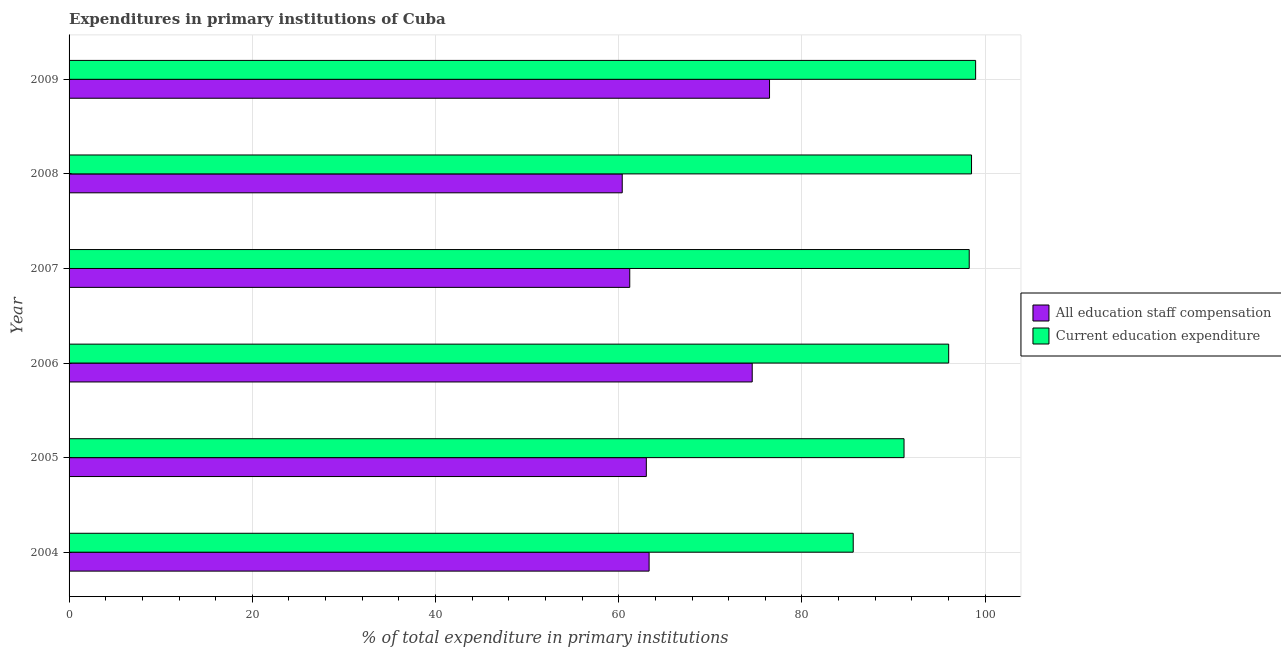How many groups of bars are there?
Provide a short and direct response. 6. Are the number of bars per tick equal to the number of legend labels?
Give a very brief answer. Yes. Are the number of bars on each tick of the Y-axis equal?
Your answer should be compact. Yes. How many bars are there on the 4th tick from the bottom?
Ensure brevity in your answer.  2. In how many cases, is the number of bars for a given year not equal to the number of legend labels?
Provide a succinct answer. 0. What is the expenditure in education in 2004?
Your response must be concise. 85.59. Across all years, what is the maximum expenditure in education?
Your answer should be compact. 98.96. Across all years, what is the minimum expenditure in staff compensation?
Ensure brevity in your answer.  60.38. In which year was the expenditure in staff compensation minimum?
Offer a very short reply. 2008. What is the total expenditure in staff compensation in the graph?
Keep it short and to the point. 398.94. What is the difference between the expenditure in staff compensation in 2004 and that in 2009?
Make the answer very short. -13.14. What is the difference between the expenditure in education in 2008 and the expenditure in staff compensation in 2004?
Provide a short and direct response. 35.19. What is the average expenditure in education per year?
Offer a terse response. 94.75. In the year 2005, what is the difference between the expenditure in staff compensation and expenditure in education?
Provide a short and direct response. -28.13. What is the ratio of the expenditure in education in 2008 to that in 2009?
Your answer should be compact. 0.99. Is the difference between the expenditure in education in 2004 and 2005 greater than the difference between the expenditure in staff compensation in 2004 and 2005?
Keep it short and to the point. No. What is the difference between the highest and the second highest expenditure in education?
Keep it short and to the point. 0.45. What is the difference between the highest and the lowest expenditure in education?
Keep it short and to the point. 13.36. In how many years, is the expenditure in education greater than the average expenditure in education taken over all years?
Your answer should be very brief. 4. Is the sum of the expenditure in education in 2004 and 2005 greater than the maximum expenditure in staff compensation across all years?
Give a very brief answer. Yes. What does the 2nd bar from the top in 2009 represents?
Your answer should be compact. All education staff compensation. What does the 2nd bar from the bottom in 2005 represents?
Your answer should be very brief. Current education expenditure. How many bars are there?
Your answer should be compact. 12. Are all the bars in the graph horizontal?
Give a very brief answer. Yes. How many years are there in the graph?
Keep it short and to the point. 6. What is the difference between two consecutive major ticks on the X-axis?
Your answer should be compact. 20. Are the values on the major ticks of X-axis written in scientific E-notation?
Make the answer very short. No. Does the graph contain any zero values?
Make the answer very short. No. Does the graph contain grids?
Provide a short and direct response. Yes. What is the title of the graph?
Provide a short and direct response. Expenditures in primary institutions of Cuba. Does "Constant 2005 US$" appear as one of the legend labels in the graph?
Your answer should be very brief. No. What is the label or title of the X-axis?
Make the answer very short. % of total expenditure in primary institutions. What is the label or title of the Y-axis?
Your answer should be compact. Year. What is the % of total expenditure in primary institutions of All education staff compensation in 2004?
Offer a terse response. 63.31. What is the % of total expenditure in primary institutions in Current education expenditure in 2004?
Your answer should be very brief. 85.59. What is the % of total expenditure in primary institutions in All education staff compensation in 2005?
Your response must be concise. 63.01. What is the % of total expenditure in primary institutions of Current education expenditure in 2005?
Keep it short and to the point. 91.14. What is the % of total expenditure in primary institutions in All education staff compensation in 2006?
Offer a very short reply. 74.57. What is the % of total expenditure in primary institutions of Current education expenditure in 2006?
Offer a very short reply. 96.02. What is the % of total expenditure in primary institutions of All education staff compensation in 2007?
Keep it short and to the point. 61.2. What is the % of total expenditure in primary institutions of Current education expenditure in 2007?
Give a very brief answer. 98.26. What is the % of total expenditure in primary institutions in All education staff compensation in 2008?
Your answer should be compact. 60.38. What is the % of total expenditure in primary institutions in Current education expenditure in 2008?
Offer a terse response. 98.51. What is the % of total expenditure in primary institutions of All education staff compensation in 2009?
Offer a very short reply. 76.46. What is the % of total expenditure in primary institutions in Current education expenditure in 2009?
Offer a terse response. 98.96. Across all years, what is the maximum % of total expenditure in primary institutions in All education staff compensation?
Offer a very short reply. 76.46. Across all years, what is the maximum % of total expenditure in primary institutions of Current education expenditure?
Your answer should be compact. 98.96. Across all years, what is the minimum % of total expenditure in primary institutions in All education staff compensation?
Your response must be concise. 60.38. Across all years, what is the minimum % of total expenditure in primary institutions in Current education expenditure?
Provide a succinct answer. 85.59. What is the total % of total expenditure in primary institutions of All education staff compensation in the graph?
Offer a very short reply. 398.94. What is the total % of total expenditure in primary institutions of Current education expenditure in the graph?
Provide a succinct answer. 568.47. What is the difference between the % of total expenditure in primary institutions in All education staff compensation in 2004 and that in 2005?
Offer a very short reply. 0.3. What is the difference between the % of total expenditure in primary institutions in Current education expenditure in 2004 and that in 2005?
Provide a short and direct response. -5.55. What is the difference between the % of total expenditure in primary institutions of All education staff compensation in 2004 and that in 2006?
Give a very brief answer. -11.26. What is the difference between the % of total expenditure in primary institutions in Current education expenditure in 2004 and that in 2006?
Make the answer very short. -10.42. What is the difference between the % of total expenditure in primary institutions of All education staff compensation in 2004 and that in 2007?
Ensure brevity in your answer.  2.11. What is the difference between the % of total expenditure in primary institutions in Current education expenditure in 2004 and that in 2007?
Offer a very short reply. -12.66. What is the difference between the % of total expenditure in primary institutions in All education staff compensation in 2004 and that in 2008?
Make the answer very short. 2.93. What is the difference between the % of total expenditure in primary institutions of Current education expenditure in 2004 and that in 2008?
Your answer should be very brief. -12.91. What is the difference between the % of total expenditure in primary institutions of All education staff compensation in 2004 and that in 2009?
Your answer should be very brief. -13.15. What is the difference between the % of total expenditure in primary institutions of Current education expenditure in 2004 and that in 2009?
Offer a very short reply. -13.36. What is the difference between the % of total expenditure in primary institutions in All education staff compensation in 2005 and that in 2006?
Your response must be concise. -11.56. What is the difference between the % of total expenditure in primary institutions in Current education expenditure in 2005 and that in 2006?
Your response must be concise. -4.87. What is the difference between the % of total expenditure in primary institutions in All education staff compensation in 2005 and that in 2007?
Your response must be concise. 1.81. What is the difference between the % of total expenditure in primary institutions of Current education expenditure in 2005 and that in 2007?
Ensure brevity in your answer.  -7.12. What is the difference between the % of total expenditure in primary institutions of All education staff compensation in 2005 and that in 2008?
Keep it short and to the point. 2.63. What is the difference between the % of total expenditure in primary institutions in Current education expenditure in 2005 and that in 2008?
Offer a very short reply. -7.37. What is the difference between the % of total expenditure in primary institutions in All education staff compensation in 2005 and that in 2009?
Offer a very short reply. -13.45. What is the difference between the % of total expenditure in primary institutions of Current education expenditure in 2005 and that in 2009?
Your answer should be compact. -7.81. What is the difference between the % of total expenditure in primary institutions in All education staff compensation in 2006 and that in 2007?
Ensure brevity in your answer.  13.37. What is the difference between the % of total expenditure in primary institutions of Current education expenditure in 2006 and that in 2007?
Offer a very short reply. -2.24. What is the difference between the % of total expenditure in primary institutions of All education staff compensation in 2006 and that in 2008?
Your response must be concise. 14.19. What is the difference between the % of total expenditure in primary institutions of Current education expenditure in 2006 and that in 2008?
Your answer should be very brief. -2.49. What is the difference between the % of total expenditure in primary institutions of All education staff compensation in 2006 and that in 2009?
Offer a terse response. -1.89. What is the difference between the % of total expenditure in primary institutions in Current education expenditure in 2006 and that in 2009?
Your answer should be very brief. -2.94. What is the difference between the % of total expenditure in primary institutions in All education staff compensation in 2007 and that in 2008?
Your answer should be compact. 0.82. What is the difference between the % of total expenditure in primary institutions in Current education expenditure in 2007 and that in 2008?
Offer a terse response. -0.25. What is the difference between the % of total expenditure in primary institutions of All education staff compensation in 2007 and that in 2009?
Offer a terse response. -15.26. What is the difference between the % of total expenditure in primary institutions in Current education expenditure in 2007 and that in 2009?
Your answer should be compact. -0.7. What is the difference between the % of total expenditure in primary institutions of All education staff compensation in 2008 and that in 2009?
Provide a short and direct response. -16.08. What is the difference between the % of total expenditure in primary institutions in Current education expenditure in 2008 and that in 2009?
Ensure brevity in your answer.  -0.45. What is the difference between the % of total expenditure in primary institutions in All education staff compensation in 2004 and the % of total expenditure in primary institutions in Current education expenditure in 2005?
Your answer should be compact. -27.83. What is the difference between the % of total expenditure in primary institutions of All education staff compensation in 2004 and the % of total expenditure in primary institutions of Current education expenditure in 2006?
Give a very brief answer. -32.7. What is the difference between the % of total expenditure in primary institutions in All education staff compensation in 2004 and the % of total expenditure in primary institutions in Current education expenditure in 2007?
Provide a succinct answer. -34.94. What is the difference between the % of total expenditure in primary institutions of All education staff compensation in 2004 and the % of total expenditure in primary institutions of Current education expenditure in 2008?
Provide a succinct answer. -35.19. What is the difference between the % of total expenditure in primary institutions in All education staff compensation in 2004 and the % of total expenditure in primary institutions in Current education expenditure in 2009?
Your answer should be compact. -35.64. What is the difference between the % of total expenditure in primary institutions of All education staff compensation in 2005 and the % of total expenditure in primary institutions of Current education expenditure in 2006?
Provide a succinct answer. -33. What is the difference between the % of total expenditure in primary institutions in All education staff compensation in 2005 and the % of total expenditure in primary institutions in Current education expenditure in 2007?
Provide a short and direct response. -35.25. What is the difference between the % of total expenditure in primary institutions in All education staff compensation in 2005 and the % of total expenditure in primary institutions in Current education expenditure in 2008?
Make the answer very short. -35.5. What is the difference between the % of total expenditure in primary institutions of All education staff compensation in 2005 and the % of total expenditure in primary institutions of Current education expenditure in 2009?
Make the answer very short. -35.94. What is the difference between the % of total expenditure in primary institutions of All education staff compensation in 2006 and the % of total expenditure in primary institutions of Current education expenditure in 2007?
Offer a terse response. -23.69. What is the difference between the % of total expenditure in primary institutions in All education staff compensation in 2006 and the % of total expenditure in primary institutions in Current education expenditure in 2008?
Make the answer very short. -23.94. What is the difference between the % of total expenditure in primary institutions in All education staff compensation in 2006 and the % of total expenditure in primary institutions in Current education expenditure in 2009?
Your answer should be very brief. -24.39. What is the difference between the % of total expenditure in primary institutions in All education staff compensation in 2007 and the % of total expenditure in primary institutions in Current education expenditure in 2008?
Your response must be concise. -37.31. What is the difference between the % of total expenditure in primary institutions of All education staff compensation in 2007 and the % of total expenditure in primary institutions of Current education expenditure in 2009?
Provide a succinct answer. -37.75. What is the difference between the % of total expenditure in primary institutions in All education staff compensation in 2008 and the % of total expenditure in primary institutions in Current education expenditure in 2009?
Keep it short and to the point. -38.57. What is the average % of total expenditure in primary institutions in All education staff compensation per year?
Give a very brief answer. 66.49. What is the average % of total expenditure in primary institutions in Current education expenditure per year?
Your response must be concise. 94.75. In the year 2004, what is the difference between the % of total expenditure in primary institutions in All education staff compensation and % of total expenditure in primary institutions in Current education expenditure?
Provide a short and direct response. -22.28. In the year 2005, what is the difference between the % of total expenditure in primary institutions of All education staff compensation and % of total expenditure in primary institutions of Current education expenditure?
Your answer should be compact. -28.13. In the year 2006, what is the difference between the % of total expenditure in primary institutions in All education staff compensation and % of total expenditure in primary institutions in Current education expenditure?
Offer a terse response. -21.45. In the year 2007, what is the difference between the % of total expenditure in primary institutions in All education staff compensation and % of total expenditure in primary institutions in Current education expenditure?
Make the answer very short. -37.06. In the year 2008, what is the difference between the % of total expenditure in primary institutions of All education staff compensation and % of total expenditure in primary institutions of Current education expenditure?
Your answer should be compact. -38.13. In the year 2009, what is the difference between the % of total expenditure in primary institutions of All education staff compensation and % of total expenditure in primary institutions of Current education expenditure?
Your answer should be very brief. -22.5. What is the ratio of the % of total expenditure in primary institutions in All education staff compensation in 2004 to that in 2005?
Keep it short and to the point. 1. What is the ratio of the % of total expenditure in primary institutions of Current education expenditure in 2004 to that in 2005?
Your answer should be very brief. 0.94. What is the ratio of the % of total expenditure in primary institutions of All education staff compensation in 2004 to that in 2006?
Give a very brief answer. 0.85. What is the ratio of the % of total expenditure in primary institutions in Current education expenditure in 2004 to that in 2006?
Provide a succinct answer. 0.89. What is the ratio of the % of total expenditure in primary institutions in All education staff compensation in 2004 to that in 2007?
Provide a short and direct response. 1.03. What is the ratio of the % of total expenditure in primary institutions of Current education expenditure in 2004 to that in 2007?
Your answer should be compact. 0.87. What is the ratio of the % of total expenditure in primary institutions in All education staff compensation in 2004 to that in 2008?
Give a very brief answer. 1.05. What is the ratio of the % of total expenditure in primary institutions in Current education expenditure in 2004 to that in 2008?
Offer a very short reply. 0.87. What is the ratio of the % of total expenditure in primary institutions of All education staff compensation in 2004 to that in 2009?
Make the answer very short. 0.83. What is the ratio of the % of total expenditure in primary institutions in Current education expenditure in 2004 to that in 2009?
Give a very brief answer. 0.86. What is the ratio of the % of total expenditure in primary institutions in All education staff compensation in 2005 to that in 2006?
Provide a short and direct response. 0.84. What is the ratio of the % of total expenditure in primary institutions in Current education expenditure in 2005 to that in 2006?
Offer a very short reply. 0.95. What is the ratio of the % of total expenditure in primary institutions of All education staff compensation in 2005 to that in 2007?
Offer a terse response. 1.03. What is the ratio of the % of total expenditure in primary institutions in Current education expenditure in 2005 to that in 2007?
Your response must be concise. 0.93. What is the ratio of the % of total expenditure in primary institutions of All education staff compensation in 2005 to that in 2008?
Your response must be concise. 1.04. What is the ratio of the % of total expenditure in primary institutions of Current education expenditure in 2005 to that in 2008?
Keep it short and to the point. 0.93. What is the ratio of the % of total expenditure in primary institutions of All education staff compensation in 2005 to that in 2009?
Make the answer very short. 0.82. What is the ratio of the % of total expenditure in primary institutions of Current education expenditure in 2005 to that in 2009?
Your response must be concise. 0.92. What is the ratio of the % of total expenditure in primary institutions of All education staff compensation in 2006 to that in 2007?
Offer a very short reply. 1.22. What is the ratio of the % of total expenditure in primary institutions of Current education expenditure in 2006 to that in 2007?
Offer a very short reply. 0.98. What is the ratio of the % of total expenditure in primary institutions of All education staff compensation in 2006 to that in 2008?
Give a very brief answer. 1.24. What is the ratio of the % of total expenditure in primary institutions of Current education expenditure in 2006 to that in 2008?
Provide a succinct answer. 0.97. What is the ratio of the % of total expenditure in primary institutions of All education staff compensation in 2006 to that in 2009?
Your answer should be very brief. 0.98. What is the ratio of the % of total expenditure in primary institutions in Current education expenditure in 2006 to that in 2009?
Your answer should be very brief. 0.97. What is the ratio of the % of total expenditure in primary institutions of All education staff compensation in 2007 to that in 2008?
Your response must be concise. 1.01. What is the ratio of the % of total expenditure in primary institutions of All education staff compensation in 2007 to that in 2009?
Your answer should be compact. 0.8. What is the ratio of the % of total expenditure in primary institutions of Current education expenditure in 2007 to that in 2009?
Provide a short and direct response. 0.99. What is the ratio of the % of total expenditure in primary institutions of All education staff compensation in 2008 to that in 2009?
Keep it short and to the point. 0.79. What is the ratio of the % of total expenditure in primary institutions in Current education expenditure in 2008 to that in 2009?
Provide a succinct answer. 1. What is the difference between the highest and the second highest % of total expenditure in primary institutions of All education staff compensation?
Offer a terse response. 1.89. What is the difference between the highest and the second highest % of total expenditure in primary institutions of Current education expenditure?
Give a very brief answer. 0.45. What is the difference between the highest and the lowest % of total expenditure in primary institutions of All education staff compensation?
Your answer should be compact. 16.08. What is the difference between the highest and the lowest % of total expenditure in primary institutions of Current education expenditure?
Your response must be concise. 13.36. 